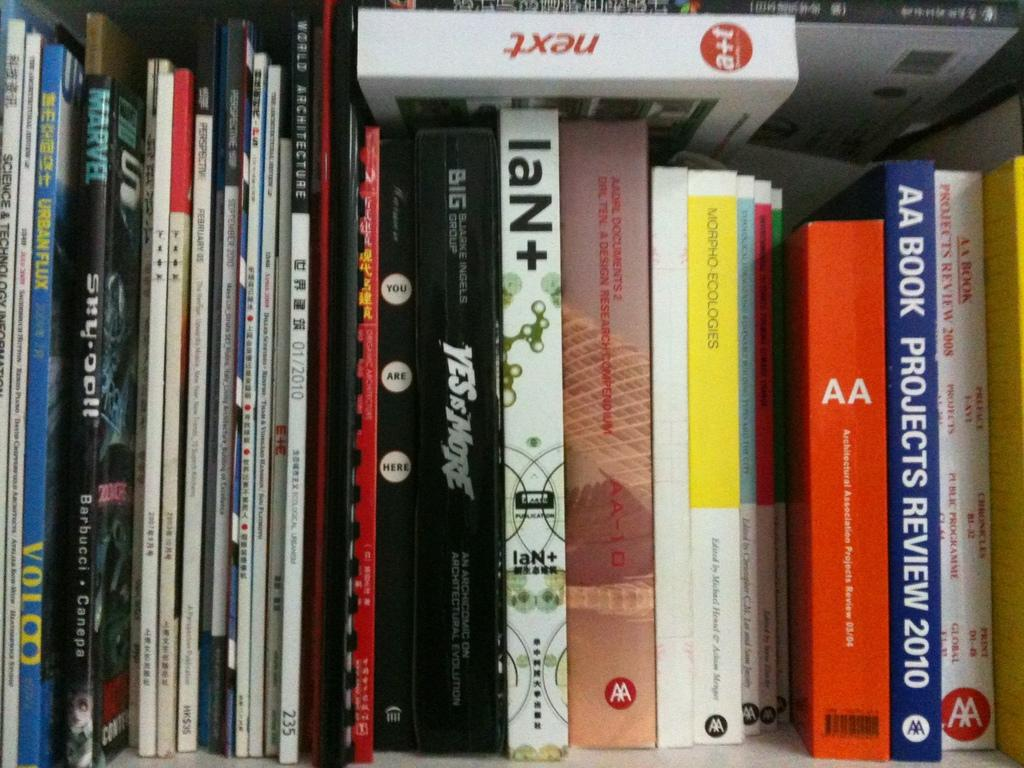<image>
Relay a brief, clear account of the picture shown. A book called IaN+ is on a bookshelf with many other books. 